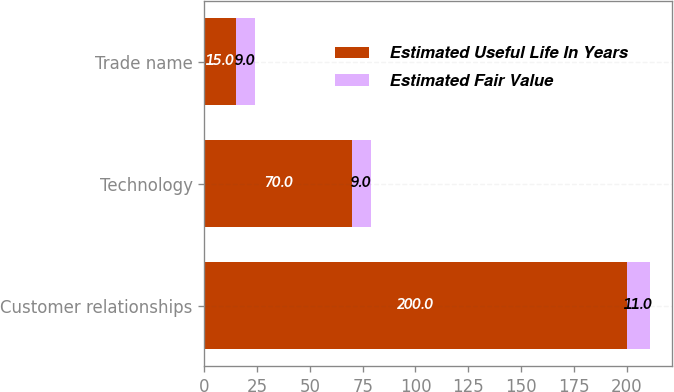<chart> <loc_0><loc_0><loc_500><loc_500><stacked_bar_chart><ecel><fcel>Customer relationships<fcel>Technology<fcel>Trade name<nl><fcel>Estimated Useful Life In Years<fcel>200<fcel>70<fcel>15<nl><fcel>Estimated Fair Value<fcel>11<fcel>9<fcel>9<nl></chart> 